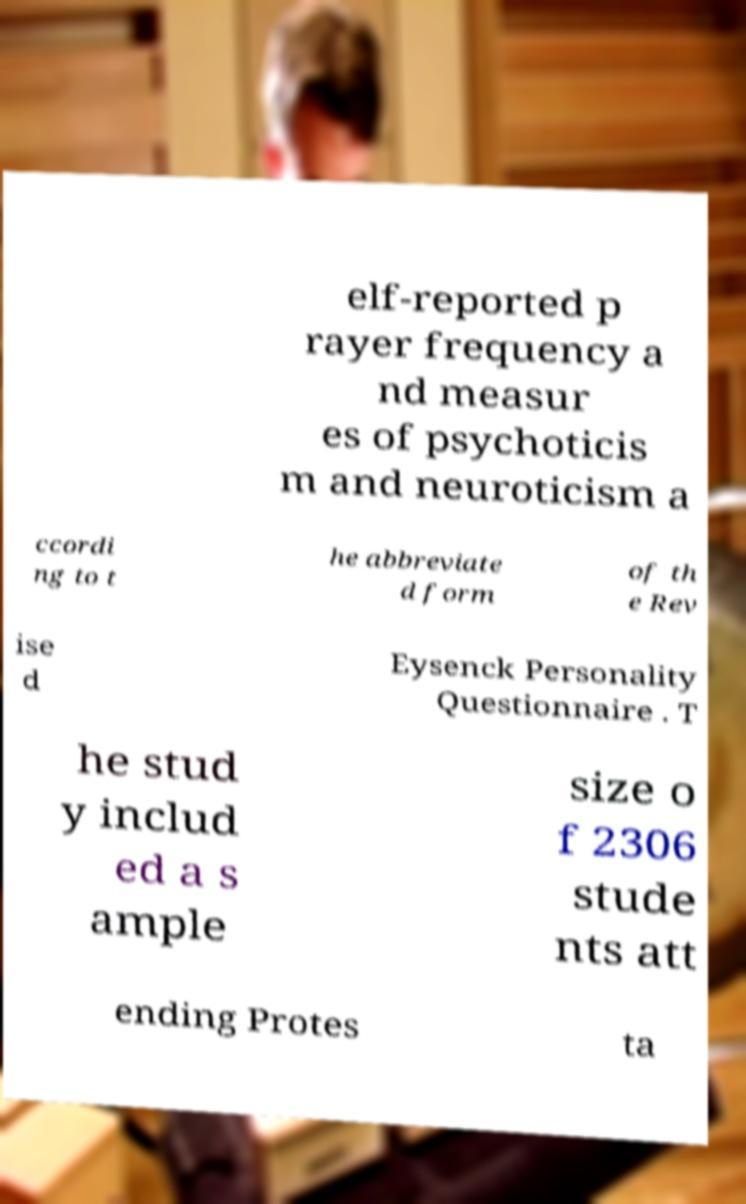Please identify and transcribe the text found in this image. elf-reported p rayer frequency a nd measur es of psychoticis m and neuroticism a ccordi ng to t he abbreviate d form of th e Rev ise d Eysenck Personality Questionnaire . T he stud y includ ed a s ample size o f 2306 stude nts att ending Protes ta 